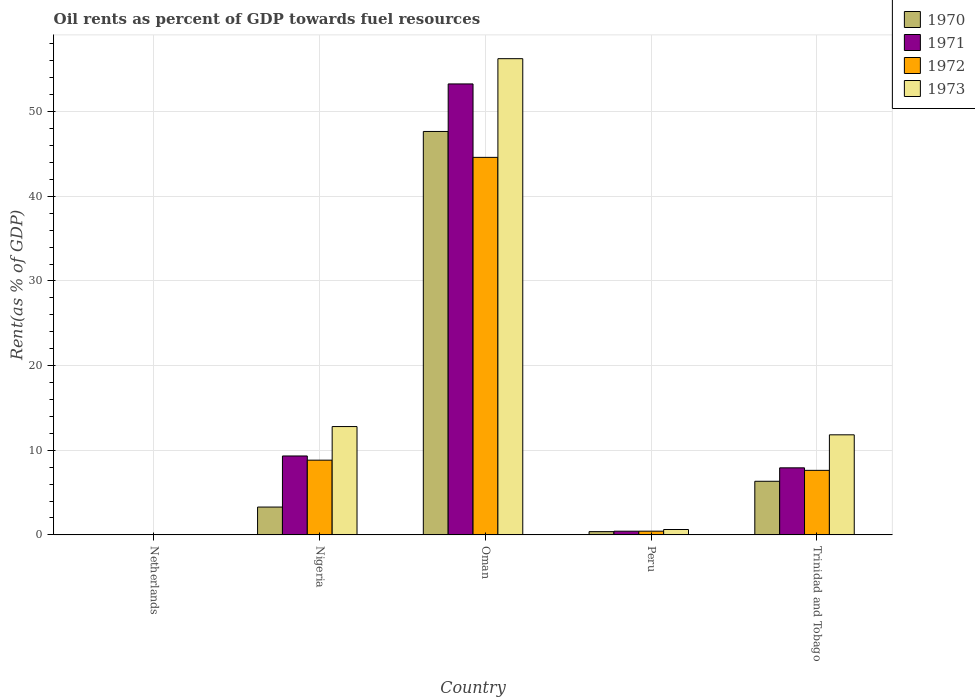How many groups of bars are there?
Your answer should be compact. 5. Are the number of bars on each tick of the X-axis equal?
Make the answer very short. Yes. How many bars are there on the 4th tick from the right?
Offer a very short reply. 4. What is the label of the 5th group of bars from the left?
Give a very brief answer. Trinidad and Tobago. What is the oil rent in 1971 in Peru?
Offer a terse response. 0.44. Across all countries, what is the maximum oil rent in 1973?
Your answer should be compact. 56.26. Across all countries, what is the minimum oil rent in 1971?
Your answer should be compact. 0.04. In which country was the oil rent in 1973 maximum?
Ensure brevity in your answer.  Oman. What is the total oil rent in 1972 in the graph?
Offer a very short reply. 61.53. What is the difference between the oil rent in 1972 in Oman and that in Peru?
Give a very brief answer. 44.16. What is the difference between the oil rent in 1970 in Nigeria and the oil rent in 1971 in Netherlands?
Your response must be concise. 3.25. What is the average oil rent in 1970 per country?
Give a very brief answer. 11.54. What is the difference between the oil rent of/in 1970 and oil rent of/in 1971 in Nigeria?
Ensure brevity in your answer.  -6.03. What is the ratio of the oil rent in 1973 in Oman to that in Trinidad and Tobago?
Provide a short and direct response. 4.76. Is the oil rent in 1970 in Oman less than that in Trinidad and Tobago?
Make the answer very short. No. Is the difference between the oil rent in 1970 in Oman and Trinidad and Tobago greater than the difference between the oil rent in 1971 in Oman and Trinidad and Tobago?
Provide a short and direct response. No. What is the difference between the highest and the second highest oil rent in 1971?
Your response must be concise. -43.95. What is the difference between the highest and the lowest oil rent in 1973?
Your answer should be very brief. 56.22. In how many countries, is the oil rent in 1973 greater than the average oil rent in 1973 taken over all countries?
Make the answer very short. 1. Is it the case that in every country, the sum of the oil rent in 1972 and oil rent in 1973 is greater than the sum of oil rent in 1970 and oil rent in 1971?
Provide a short and direct response. No. What does the 3rd bar from the right in Oman represents?
Give a very brief answer. 1971. How many bars are there?
Make the answer very short. 20. How many legend labels are there?
Offer a very short reply. 4. What is the title of the graph?
Your answer should be compact. Oil rents as percent of GDP towards fuel resources. Does "1998" appear as one of the legend labels in the graph?
Your response must be concise. No. What is the label or title of the Y-axis?
Provide a short and direct response. Rent(as % of GDP). What is the Rent(as % of GDP) of 1970 in Netherlands?
Offer a terse response. 0.04. What is the Rent(as % of GDP) in 1971 in Netherlands?
Keep it short and to the point. 0.04. What is the Rent(as % of GDP) in 1972 in Netherlands?
Offer a terse response. 0.03. What is the Rent(as % of GDP) of 1973 in Netherlands?
Your answer should be compact. 0.04. What is the Rent(as % of GDP) of 1970 in Nigeria?
Make the answer very short. 3.29. What is the Rent(as % of GDP) of 1971 in Nigeria?
Offer a very short reply. 9.32. What is the Rent(as % of GDP) of 1972 in Nigeria?
Offer a terse response. 8.83. What is the Rent(as % of GDP) in 1973 in Nigeria?
Your answer should be compact. 12.8. What is the Rent(as % of GDP) in 1970 in Oman?
Your response must be concise. 47.66. What is the Rent(as % of GDP) of 1971 in Oman?
Keep it short and to the point. 53.28. What is the Rent(as % of GDP) in 1972 in Oman?
Your response must be concise. 44.6. What is the Rent(as % of GDP) of 1973 in Oman?
Give a very brief answer. 56.26. What is the Rent(as % of GDP) in 1970 in Peru?
Provide a short and direct response. 0.39. What is the Rent(as % of GDP) in 1971 in Peru?
Provide a succinct answer. 0.44. What is the Rent(as % of GDP) in 1972 in Peru?
Offer a very short reply. 0.44. What is the Rent(as % of GDP) in 1973 in Peru?
Your response must be concise. 0.64. What is the Rent(as % of GDP) of 1970 in Trinidad and Tobago?
Your answer should be very brief. 6.33. What is the Rent(as % of GDP) in 1971 in Trinidad and Tobago?
Keep it short and to the point. 7.92. What is the Rent(as % of GDP) of 1972 in Trinidad and Tobago?
Give a very brief answer. 7.63. What is the Rent(as % of GDP) of 1973 in Trinidad and Tobago?
Keep it short and to the point. 11.82. Across all countries, what is the maximum Rent(as % of GDP) in 1970?
Your answer should be very brief. 47.66. Across all countries, what is the maximum Rent(as % of GDP) in 1971?
Keep it short and to the point. 53.28. Across all countries, what is the maximum Rent(as % of GDP) of 1972?
Your answer should be very brief. 44.6. Across all countries, what is the maximum Rent(as % of GDP) of 1973?
Keep it short and to the point. 56.26. Across all countries, what is the minimum Rent(as % of GDP) in 1970?
Your response must be concise. 0.04. Across all countries, what is the minimum Rent(as % of GDP) in 1971?
Ensure brevity in your answer.  0.04. Across all countries, what is the minimum Rent(as % of GDP) in 1972?
Offer a very short reply. 0.03. Across all countries, what is the minimum Rent(as % of GDP) in 1973?
Give a very brief answer. 0.04. What is the total Rent(as % of GDP) of 1970 in the graph?
Provide a succinct answer. 57.71. What is the total Rent(as % of GDP) in 1971 in the graph?
Provide a short and direct response. 71. What is the total Rent(as % of GDP) in 1972 in the graph?
Make the answer very short. 61.53. What is the total Rent(as % of GDP) of 1973 in the graph?
Offer a terse response. 81.56. What is the difference between the Rent(as % of GDP) of 1970 in Netherlands and that in Nigeria?
Your response must be concise. -3.25. What is the difference between the Rent(as % of GDP) of 1971 in Netherlands and that in Nigeria?
Offer a very short reply. -9.28. What is the difference between the Rent(as % of GDP) in 1972 in Netherlands and that in Nigeria?
Your answer should be compact. -8.79. What is the difference between the Rent(as % of GDP) of 1973 in Netherlands and that in Nigeria?
Offer a terse response. -12.76. What is the difference between the Rent(as % of GDP) in 1970 in Netherlands and that in Oman?
Offer a very short reply. -47.62. What is the difference between the Rent(as % of GDP) of 1971 in Netherlands and that in Oman?
Make the answer very short. -53.23. What is the difference between the Rent(as % of GDP) in 1972 in Netherlands and that in Oman?
Your answer should be very brief. -44.57. What is the difference between the Rent(as % of GDP) of 1973 in Netherlands and that in Oman?
Keep it short and to the point. -56.22. What is the difference between the Rent(as % of GDP) of 1970 in Netherlands and that in Peru?
Offer a terse response. -0.35. What is the difference between the Rent(as % of GDP) in 1971 in Netherlands and that in Peru?
Make the answer very short. -0.39. What is the difference between the Rent(as % of GDP) in 1972 in Netherlands and that in Peru?
Provide a succinct answer. -0.4. What is the difference between the Rent(as % of GDP) in 1973 in Netherlands and that in Peru?
Provide a succinct answer. -0.6. What is the difference between the Rent(as % of GDP) in 1970 in Netherlands and that in Trinidad and Tobago?
Keep it short and to the point. -6.3. What is the difference between the Rent(as % of GDP) of 1971 in Netherlands and that in Trinidad and Tobago?
Make the answer very short. -7.88. What is the difference between the Rent(as % of GDP) in 1972 in Netherlands and that in Trinidad and Tobago?
Give a very brief answer. -7.59. What is the difference between the Rent(as % of GDP) in 1973 in Netherlands and that in Trinidad and Tobago?
Provide a short and direct response. -11.78. What is the difference between the Rent(as % of GDP) in 1970 in Nigeria and that in Oman?
Ensure brevity in your answer.  -44.37. What is the difference between the Rent(as % of GDP) of 1971 in Nigeria and that in Oman?
Give a very brief answer. -43.95. What is the difference between the Rent(as % of GDP) of 1972 in Nigeria and that in Oman?
Your answer should be very brief. -35.77. What is the difference between the Rent(as % of GDP) of 1973 in Nigeria and that in Oman?
Offer a terse response. -43.46. What is the difference between the Rent(as % of GDP) in 1970 in Nigeria and that in Peru?
Make the answer very short. 2.9. What is the difference between the Rent(as % of GDP) in 1971 in Nigeria and that in Peru?
Provide a succinct answer. 8.89. What is the difference between the Rent(as % of GDP) in 1972 in Nigeria and that in Peru?
Keep it short and to the point. 8.39. What is the difference between the Rent(as % of GDP) of 1973 in Nigeria and that in Peru?
Keep it short and to the point. 12.16. What is the difference between the Rent(as % of GDP) of 1970 in Nigeria and that in Trinidad and Tobago?
Give a very brief answer. -3.04. What is the difference between the Rent(as % of GDP) of 1971 in Nigeria and that in Trinidad and Tobago?
Make the answer very short. 1.4. What is the difference between the Rent(as % of GDP) of 1972 in Nigeria and that in Trinidad and Tobago?
Make the answer very short. 1.2. What is the difference between the Rent(as % of GDP) of 1973 in Nigeria and that in Trinidad and Tobago?
Give a very brief answer. 0.98. What is the difference between the Rent(as % of GDP) in 1970 in Oman and that in Peru?
Offer a very short reply. 47.28. What is the difference between the Rent(as % of GDP) of 1971 in Oman and that in Peru?
Your answer should be very brief. 52.84. What is the difference between the Rent(as % of GDP) of 1972 in Oman and that in Peru?
Provide a short and direct response. 44.16. What is the difference between the Rent(as % of GDP) of 1973 in Oman and that in Peru?
Provide a short and direct response. 55.62. What is the difference between the Rent(as % of GDP) of 1970 in Oman and that in Trinidad and Tobago?
Ensure brevity in your answer.  41.33. What is the difference between the Rent(as % of GDP) in 1971 in Oman and that in Trinidad and Tobago?
Ensure brevity in your answer.  45.35. What is the difference between the Rent(as % of GDP) in 1972 in Oman and that in Trinidad and Tobago?
Offer a very short reply. 36.97. What is the difference between the Rent(as % of GDP) in 1973 in Oman and that in Trinidad and Tobago?
Provide a succinct answer. 44.44. What is the difference between the Rent(as % of GDP) of 1970 in Peru and that in Trinidad and Tobago?
Make the answer very short. -5.95. What is the difference between the Rent(as % of GDP) in 1971 in Peru and that in Trinidad and Tobago?
Offer a very short reply. -7.49. What is the difference between the Rent(as % of GDP) of 1972 in Peru and that in Trinidad and Tobago?
Offer a terse response. -7.19. What is the difference between the Rent(as % of GDP) in 1973 in Peru and that in Trinidad and Tobago?
Make the answer very short. -11.19. What is the difference between the Rent(as % of GDP) in 1970 in Netherlands and the Rent(as % of GDP) in 1971 in Nigeria?
Your answer should be compact. -9.29. What is the difference between the Rent(as % of GDP) of 1970 in Netherlands and the Rent(as % of GDP) of 1972 in Nigeria?
Offer a very short reply. -8.79. What is the difference between the Rent(as % of GDP) in 1970 in Netherlands and the Rent(as % of GDP) in 1973 in Nigeria?
Provide a short and direct response. -12.76. What is the difference between the Rent(as % of GDP) in 1971 in Netherlands and the Rent(as % of GDP) in 1972 in Nigeria?
Offer a very short reply. -8.79. What is the difference between the Rent(as % of GDP) of 1971 in Netherlands and the Rent(as % of GDP) of 1973 in Nigeria?
Provide a short and direct response. -12.76. What is the difference between the Rent(as % of GDP) in 1972 in Netherlands and the Rent(as % of GDP) in 1973 in Nigeria?
Your answer should be compact. -12.76. What is the difference between the Rent(as % of GDP) of 1970 in Netherlands and the Rent(as % of GDP) of 1971 in Oman?
Offer a terse response. -53.24. What is the difference between the Rent(as % of GDP) of 1970 in Netherlands and the Rent(as % of GDP) of 1972 in Oman?
Keep it short and to the point. -44.56. What is the difference between the Rent(as % of GDP) of 1970 in Netherlands and the Rent(as % of GDP) of 1973 in Oman?
Give a very brief answer. -56.22. What is the difference between the Rent(as % of GDP) of 1971 in Netherlands and the Rent(as % of GDP) of 1972 in Oman?
Offer a terse response. -44.56. What is the difference between the Rent(as % of GDP) of 1971 in Netherlands and the Rent(as % of GDP) of 1973 in Oman?
Provide a short and direct response. -56.22. What is the difference between the Rent(as % of GDP) of 1972 in Netherlands and the Rent(as % of GDP) of 1973 in Oman?
Your response must be concise. -56.22. What is the difference between the Rent(as % of GDP) in 1970 in Netherlands and the Rent(as % of GDP) in 1971 in Peru?
Give a very brief answer. -0.4. What is the difference between the Rent(as % of GDP) of 1970 in Netherlands and the Rent(as % of GDP) of 1972 in Peru?
Provide a succinct answer. -0.4. What is the difference between the Rent(as % of GDP) in 1970 in Netherlands and the Rent(as % of GDP) in 1973 in Peru?
Your answer should be compact. -0.6. What is the difference between the Rent(as % of GDP) in 1971 in Netherlands and the Rent(as % of GDP) in 1972 in Peru?
Ensure brevity in your answer.  -0.4. What is the difference between the Rent(as % of GDP) of 1971 in Netherlands and the Rent(as % of GDP) of 1973 in Peru?
Your answer should be compact. -0.59. What is the difference between the Rent(as % of GDP) of 1972 in Netherlands and the Rent(as % of GDP) of 1973 in Peru?
Give a very brief answer. -0.6. What is the difference between the Rent(as % of GDP) of 1970 in Netherlands and the Rent(as % of GDP) of 1971 in Trinidad and Tobago?
Keep it short and to the point. -7.88. What is the difference between the Rent(as % of GDP) in 1970 in Netherlands and the Rent(as % of GDP) in 1972 in Trinidad and Tobago?
Provide a succinct answer. -7.59. What is the difference between the Rent(as % of GDP) in 1970 in Netherlands and the Rent(as % of GDP) in 1973 in Trinidad and Tobago?
Keep it short and to the point. -11.79. What is the difference between the Rent(as % of GDP) of 1971 in Netherlands and the Rent(as % of GDP) of 1972 in Trinidad and Tobago?
Your answer should be compact. -7.58. What is the difference between the Rent(as % of GDP) of 1971 in Netherlands and the Rent(as % of GDP) of 1973 in Trinidad and Tobago?
Ensure brevity in your answer.  -11.78. What is the difference between the Rent(as % of GDP) in 1972 in Netherlands and the Rent(as % of GDP) in 1973 in Trinidad and Tobago?
Your response must be concise. -11.79. What is the difference between the Rent(as % of GDP) of 1970 in Nigeria and the Rent(as % of GDP) of 1971 in Oman?
Give a very brief answer. -49.99. What is the difference between the Rent(as % of GDP) of 1970 in Nigeria and the Rent(as % of GDP) of 1972 in Oman?
Ensure brevity in your answer.  -41.31. What is the difference between the Rent(as % of GDP) of 1970 in Nigeria and the Rent(as % of GDP) of 1973 in Oman?
Keep it short and to the point. -52.97. What is the difference between the Rent(as % of GDP) of 1971 in Nigeria and the Rent(as % of GDP) of 1972 in Oman?
Offer a very short reply. -35.28. What is the difference between the Rent(as % of GDP) of 1971 in Nigeria and the Rent(as % of GDP) of 1973 in Oman?
Provide a short and direct response. -46.94. What is the difference between the Rent(as % of GDP) of 1972 in Nigeria and the Rent(as % of GDP) of 1973 in Oman?
Provide a succinct answer. -47.43. What is the difference between the Rent(as % of GDP) of 1970 in Nigeria and the Rent(as % of GDP) of 1971 in Peru?
Your response must be concise. 2.85. What is the difference between the Rent(as % of GDP) of 1970 in Nigeria and the Rent(as % of GDP) of 1972 in Peru?
Provide a succinct answer. 2.85. What is the difference between the Rent(as % of GDP) of 1970 in Nigeria and the Rent(as % of GDP) of 1973 in Peru?
Give a very brief answer. 2.65. What is the difference between the Rent(as % of GDP) in 1971 in Nigeria and the Rent(as % of GDP) in 1972 in Peru?
Provide a short and direct response. 8.88. What is the difference between the Rent(as % of GDP) of 1971 in Nigeria and the Rent(as % of GDP) of 1973 in Peru?
Make the answer very short. 8.69. What is the difference between the Rent(as % of GDP) in 1972 in Nigeria and the Rent(as % of GDP) in 1973 in Peru?
Give a very brief answer. 8.19. What is the difference between the Rent(as % of GDP) of 1970 in Nigeria and the Rent(as % of GDP) of 1971 in Trinidad and Tobago?
Your answer should be very brief. -4.63. What is the difference between the Rent(as % of GDP) of 1970 in Nigeria and the Rent(as % of GDP) of 1972 in Trinidad and Tobago?
Provide a short and direct response. -4.34. What is the difference between the Rent(as % of GDP) in 1970 in Nigeria and the Rent(as % of GDP) in 1973 in Trinidad and Tobago?
Your answer should be very brief. -8.53. What is the difference between the Rent(as % of GDP) of 1971 in Nigeria and the Rent(as % of GDP) of 1972 in Trinidad and Tobago?
Your answer should be very brief. 1.7. What is the difference between the Rent(as % of GDP) of 1972 in Nigeria and the Rent(as % of GDP) of 1973 in Trinidad and Tobago?
Give a very brief answer. -2.99. What is the difference between the Rent(as % of GDP) of 1970 in Oman and the Rent(as % of GDP) of 1971 in Peru?
Offer a terse response. 47.23. What is the difference between the Rent(as % of GDP) of 1970 in Oman and the Rent(as % of GDP) of 1972 in Peru?
Offer a very short reply. 47.22. What is the difference between the Rent(as % of GDP) of 1970 in Oman and the Rent(as % of GDP) of 1973 in Peru?
Provide a succinct answer. 47.03. What is the difference between the Rent(as % of GDP) in 1971 in Oman and the Rent(as % of GDP) in 1972 in Peru?
Your answer should be compact. 52.84. What is the difference between the Rent(as % of GDP) of 1971 in Oman and the Rent(as % of GDP) of 1973 in Peru?
Offer a terse response. 52.64. What is the difference between the Rent(as % of GDP) in 1972 in Oman and the Rent(as % of GDP) in 1973 in Peru?
Keep it short and to the point. 43.96. What is the difference between the Rent(as % of GDP) of 1970 in Oman and the Rent(as % of GDP) of 1971 in Trinidad and Tobago?
Offer a terse response. 39.74. What is the difference between the Rent(as % of GDP) of 1970 in Oman and the Rent(as % of GDP) of 1972 in Trinidad and Tobago?
Your answer should be very brief. 40.04. What is the difference between the Rent(as % of GDP) of 1970 in Oman and the Rent(as % of GDP) of 1973 in Trinidad and Tobago?
Keep it short and to the point. 35.84. What is the difference between the Rent(as % of GDP) of 1971 in Oman and the Rent(as % of GDP) of 1972 in Trinidad and Tobago?
Make the answer very short. 45.65. What is the difference between the Rent(as % of GDP) in 1971 in Oman and the Rent(as % of GDP) in 1973 in Trinidad and Tobago?
Offer a very short reply. 41.45. What is the difference between the Rent(as % of GDP) in 1972 in Oman and the Rent(as % of GDP) in 1973 in Trinidad and Tobago?
Keep it short and to the point. 32.78. What is the difference between the Rent(as % of GDP) in 1970 in Peru and the Rent(as % of GDP) in 1971 in Trinidad and Tobago?
Your answer should be very brief. -7.54. What is the difference between the Rent(as % of GDP) of 1970 in Peru and the Rent(as % of GDP) of 1972 in Trinidad and Tobago?
Your answer should be very brief. -7.24. What is the difference between the Rent(as % of GDP) of 1970 in Peru and the Rent(as % of GDP) of 1973 in Trinidad and Tobago?
Provide a short and direct response. -11.44. What is the difference between the Rent(as % of GDP) in 1971 in Peru and the Rent(as % of GDP) in 1972 in Trinidad and Tobago?
Provide a short and direct response. -7.19. What is the difference between the Rent(as % of GDP) in 1971 in Peru and the Rent(as % of GDP) in 1973 in Trinidad and Tobago?
Keep it short and to the point. -11.39. What is the difference between the Rent(as % of GDP) of 1972 in Peru and the Rent(as % of GDP) of 1973 in Trinidad and Tobago?
Provide a short and direct response. -11.38. What is the average Rent(as % of GDP) in 1970 per country?
Offer a very short reply. 11.54. What is the average Rent(as % of GDP) in 1971 per country?
Your answer should be very brief. 14.2. What is the average Rent(as % of GDP) of 1972 per country?
Make the answer very short. 12.31. What is the average Rent(as % of GDP) in 1973 per country?
Provide a succinct answer. 16.31. What is the difference between the Rent(as % of GDP) of 1970 and Rent(as % of GDP) of 1971 in Netherlands?
Provide a short and direct response. -0.01. What is the difference between the Rent(as % of GDP) of 1970 and Rent(as % of GDP) of 1972 in Netherlands?
Offer a terse response. 0. What is the difference between the Rent(as % of GDP) of 1970 and Rent(as % of GDP) of 1973 in Netherlands?
Keep it short and to the point. -0. What is the difference between the Rent(as % of GDP) in 1971 and Rent(as % of GDP) in 1972 in Netherlands?
Make the answer very short. 0.01. What is the difference between the Rent(as % of GDP) in 1971 and Rent(as % of GDP) in 1973 in Netherlands?
Your answer should be compact. 0. What is the difference between the Rent(as % of GDP) in 1972 and Rent(as % of GDP) in 1973 in Netherlands?
Provide a succinct answer. -0. What is the difference between the Rent(as % of GDP) in 1970 and Rent(as % of GDP) in 1971 in Nigeria?
Your response must be concise. -6.03. What is the difference between the Rent(as % of GDP) in 1970 and Rent(as % of GDP) in 1972 in Nigeria?
Offer a terse response. -5.54. What is the difference between the Rent(as % of GDP) in 1970 and Rent(as % of GDP) in 1973 in Nigeria?
Offer a terse response. -9.51. What is the difference between the Rent(as % of GDP) in 1971 and Rent(as % of GDP) in 1972 in Nigeria?
Give a very brief answer. 0.49. What is the difference between the Rent(as % of GDP) in 1971 and Rent(as % of GDP) in 1973 in Nigeria?
Keep it short and to the point. -3.48. What is the difference between the Rent(as % of GDP) in 1972 and Rent(as % of GDP) in 1973 in Nigeria?
Make the answer very short. -3.97. What is the difference between the Rent(as % of GDP) in 1970 and Rent(as % of GDP) in 1971 in Oman?
Keep it short and to the point. -5.61. What is the difference between the Rent(as % of GDP) of 1970 and Rent(as % of GDP) of 1972 in Oman?
Offer a terse response. 3.06. What is the difference between the Rent(as % of GDP) of 1970 and Rent(as % of GDP) of 1973 in Oman?
Keep it short and to the point. -8.6. What is the difference between the Rent(as % of GDP) in 1971 and Rent(as % of GDP) in 1972 in Oman?
Give a very brief answer. 8.68. What is the difference between the Rent(as % of GDP) in 1971 and Rent(as % of GDP) in 1973 in Oman?
Your response must be concise. -2.98. What is the difference between the Rent(as % of GDP) of 1972 and Rent(as % of GDP) of 1973 in Oman?
Provide a succinct answer. -11.66. What is the difference between the Rent(as % of GDP) in 1970 and Rent(as % of GDP) in 1971 in Peru?
Offer a terse response. -0.05. What is the difference between the Rent(as % of GDP) of 1970 and Rent(as % of GDP) of 1972 in Peru?
Keep it short and to the point. -0.05. What is the difference between the Rent(as % of GDP) in 1970 and Rent(as % of GDP) in 1973 in Peru?
Your answer should be very brief. -0.25. What is the difference between the Rent(as % of GDP) of 1971 and Rent(as % of GDP) of 1972 in Peru?
Your answer should be very brief. -0. What is the difference between the Rent(as % of GDP) of 1971 and Rent(as % of GDP) of 1973 in Peru?
Make the answer very short. -0.2. What is the difference between the Rent(as % of GDP) in 1972 and Rent(as % of GDP) in 1973 in Peru?
Your answer should be compact. -0.2. What is the difference between the Rent(as % of GDP) of 1970 and Rent(as % of GDP) of 1971 in Trinidad and Tobago?
Offer a terse response. -1.59. What is the difference between the Rent(as % of GDP) of 1970 and Rent(as % of GDP) of 1972 in Trinidad and Tobago?
Offer a terse response. -1.29. What is the difference between the Rent(as % of GDP) in 1970 and Rent(as % of GDP) in 1973 in Trinidad and Tobago?
Make the answer very short. -5.49. What is the difference between the Rent(as % of GDP) in 1971 and Rent(as % of GDP) in 1972 in Trinidad and Tobago?
Keep it short and to the point. 0.3. What is the difference between the Rent(as % of GDP) in 1971 and Rent(as % of GDP) in 1973 in Trinidad and Tobago?
Provide a short and direct response. -3.9. What is the difference between the Rent(as % of GDP) in 1972 and Rent(as % of GDP) in 1973 in Trinidad and Tobago?
Offer a very short reply. -4.2. What is the ratio of the Rent(as % of GDP) of 1970 in Netherlands to that in Nigeria?
Offer a terse response. 0.01. What is the ratio of the Rent(as % of GDP) in 1971 in Netherlands to that in Nigeria?
Keep it short and to the point. 0. What is the ratio of the Rent(as % of GDP) of 1972 in Netherlands to that in Nigeria?
Your answer should be very brief. 0. What is the ratio of the Rent(as % of GDP) of 1973 in Netherlands to that in Nigeria?
Ensure brevity in your answer.  0. What is the ratio of the Rent(as % of GDP) in 1970 in Netherlands to that in Oman?
Provide a succinct answer. 0. What is the ratio of the Rent(as % of GDP) of 1971 in Netherlands to that in Oman?
Offer a very short reply. 0. What is the ratio of the Rent(as % of GDP) of 1972 in Netherlands to that in Oman?
Provide a short and direct response. 0. What is the ratio of the Rent(as % of GDP) of 1973 in Netherlands to that in Oman?
Your response must be concise. 0. What is the ratio of the Rent(as % of GDP) of 1970 in Netherlands to that in Peru?
Ensure brevity in your answer.  0.1. What is the ratio of the Rent(as % of GDP) in 1971 in Netherlands to that in Peru?
Your response must be concise. 0.1. What is the ratio of the Rent(as % of GDP) of 1972 in Netherlands to that in Peru?
Offer a terse response. 0.08. What is the ratio of the Rent(as % of GDP) of 1973 in Netherlands to that in Peru?
Provide a short and direct response. 0.06. What is the ratio of the Rent(as % of GDP) in 1970 in Netherlands to that in Trinidad and Tobago?
Ensure brevity in your answer.  0.01. What is the ratio of the Rent(as % of GDP) of 1971 in Netherlands to that in Trinidad and Tobago?
Provide a short and direct response. 0.01. What is the ratio of the Rent(as % of GDP) of 1972 in Netherlands to that in Trinidad and Tobago?
Provide a short and direct response. 0. What is the ratio of the Rent(as % of GDP) in 1973 in Netherlands to that in Trinidad and Tobago?
Offer a very short reply. 0. What is the ratio of the Rent(as % of GDP) in 1970 in Nigeria to that in Oman?
Make the answer very short. 0.07. What is the ratio of the Rent(as % of GDP) of 1971 in Nigeria to that in Oman?
Keep it short and to the point. 0.17. What is the ratio of the Rent(as % of GDP) in 1972 in Nigeria to that in Oman?
Provide a short and direct response. 0.2. What is the ratio of the Rent(as % of GDP) in 1973 in Nigeria to that in Oman?
Keep it short and to the point. 0.23. What is the ratio of the Rent(as % of GDP) in 1970 in Nigeria to that in Peru?
Your answer should be compact. 8.53. What is the ratio of the Rent(as % of GDP) in 1971 in Nigeria to that in Peru?
Ensure brevity in your answer.  21.35. What is the ratio of the Rent(as % of GDP) of 1972 in Nigeria to that in Peru?
Your answer should be very brief. 20.12. What is the ratio of the Rent(as % of GDP) of 1973 in Nigeria to that in Peru?
Your answer should be very brief. 20.13. What is the ratio of the Rent(as % of GDP) in 1970 in Nigeria to that in Trinidad and Tobago?
Offer a very short reply. 0.52. What is the ratio of the Rent(as % of GDP) of 1971 in Nigeria to that in Trinidad and Tobago?
Your response must be concise. 1.18. What is the ratio of the Rent(as % of GDP) in 1972 in Nigeria to that in Trinidad and Tobago?
Make the answer very short. 1.16. What is the ratio of the Rent(as % of GDP) in 1973 in Nigeria to that in Trinidad and Tobago?
Make the answer very short. 1.08. What is the ratio of the Rent(as % of GDP) of 1970 in Oman to that in Peru?
Your answer should be very brief. 123.65. What is the ratio of the Rent(as % of GDP) in 1971 in Oman to that in Peru?
Your response must be concise. 121.98. What is the ratio of the Rent(as % of GDP) of 1972 in Oman to that in Peru?
Give a very brief answer. 101.64. What is the ratio of the Rent(as % of GDP) of 1973 in Oman to that in Peru?
Ensure brevity in your answer.  88.49. What is the ratio of the Rent(as % of GDP) of 1970 in Oman to that in Trinidad and Tobago?
Provide a short and direct response. 7.52. What is the ratio of the Rent(as % of GDP) of 1971 in Oman to that in Trinidad and Tobago?
Provide a succinct answer. 6.73. What is the ratio of the Rent(as % of GDP) of 1972 in Oman to that in Trinidad and Tobago?
Make the answer very short. 5.85. What is the ratio of the Rent(as % of GDP) of 1973 in Oman to that in Trinidad and Tobago?
Keep it short and to the point. 4.76. What is the ratio of the Rent(as % of GDP) of 1970 in Peru to that in Trinidad and Tobago?
Offer a very short reply. 0.06. What is the ratio of the Rent(as % of GDP) of 1971 in Peru to that in Trinidad and Tobago?
Give a very brief answer. 0.06. What is the ratio of the Rent(as % of GDP) in 1972 in Peru to that in Trinidad and Tobago?
Give a very brief answer. 0.06. What is the ratio of the Rent(as % of GDP) in 1973 in Peru to that in Trinidad and Tobago?
Your answer should be compact. 0.05. What is the difference between the highest and the second highest Rent(as % of GDP) of 1970?
Ensure brevity in your answer.  41.33. What is the difference between the highest and the second highest Rent(as % of GDP) in 1971?
Provide a short and direct response. 43.95. What is the difference between the highest and the second highest Rent(as % of GDP) in 1972?
Provide a succinct answer. 35.77. What is the difference between the highest and the second highest Rent(as % of GDP) of 1973?
Ensure brevity in your answer.  43.46. What is the difference between the highest and the lowest Rent(as % of GDP) in 1970?
Make the answer very short. 47.62. What is the difference between the highest and the lowest Rent(as % of GDP) of 1971?
Your response must be concise. 53.23. What is the difference between the highest and the lowest Rent(as % of GDP) in 1972?
Provide a succinct answer. 44.57. What is the difference between the highest and the lowest Rent(as % of GDP) in 1973?
Offer a terse response. 56.22. 